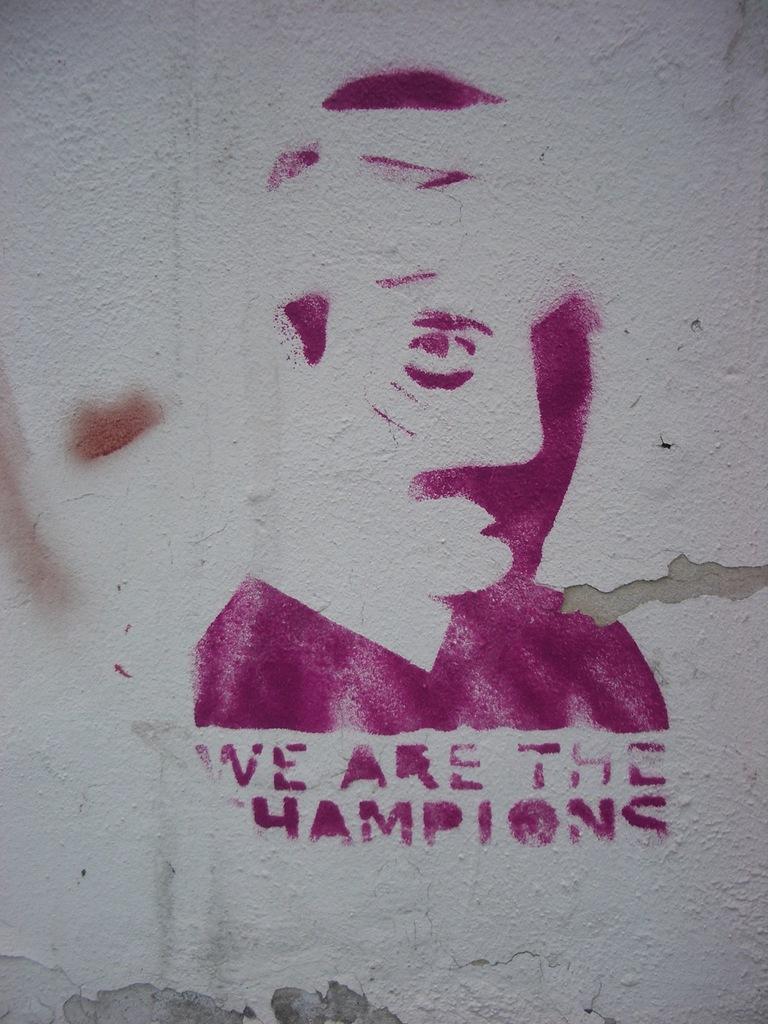How would you summarize this image in a sentence or two? IN this picture, there is a painting and some text on the wall. 